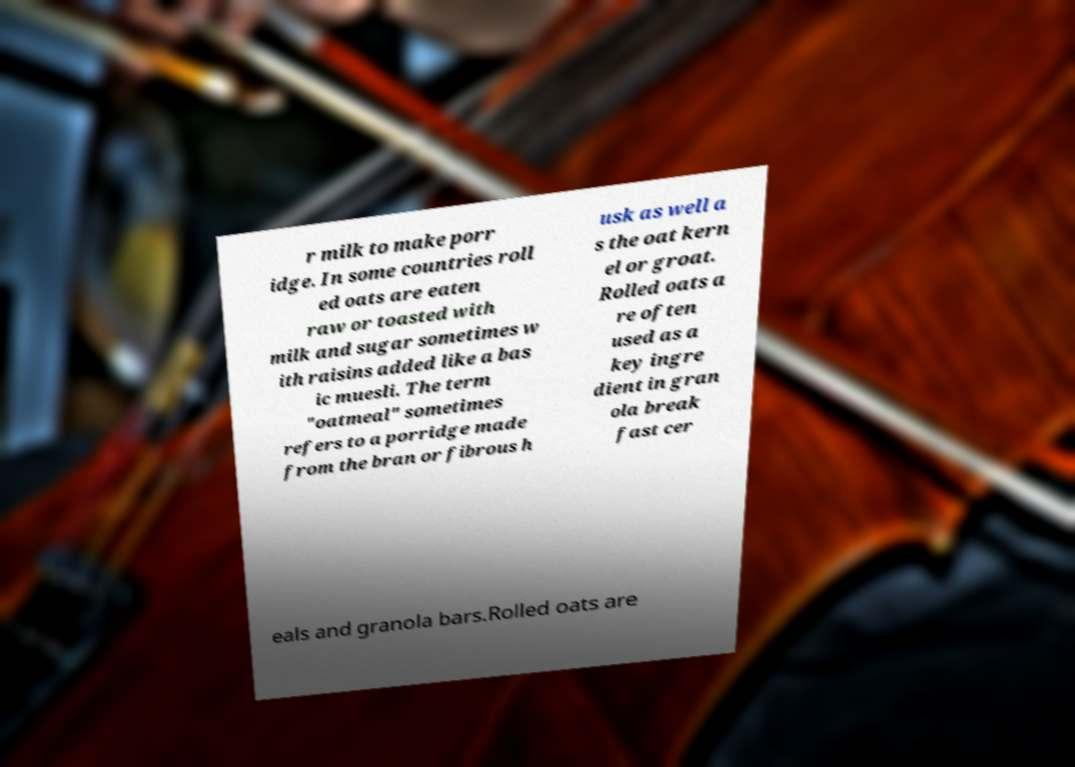I need the written content from this picture converted into text. Can you do that? r milk to make porr idge. In some countries roll ed oats are eaten raw or toasted with milk and sugar sometimes w ith raisins added like a bas ic muesli. The term "oatmeal" sometimes refers to a porridge made from the bran or fibrous h usk as well a s the oat kern el or groat. Rolled oats a re often used as a key ingre dient in gran ola break fast cer eals and granola bars.Rolled oats are 